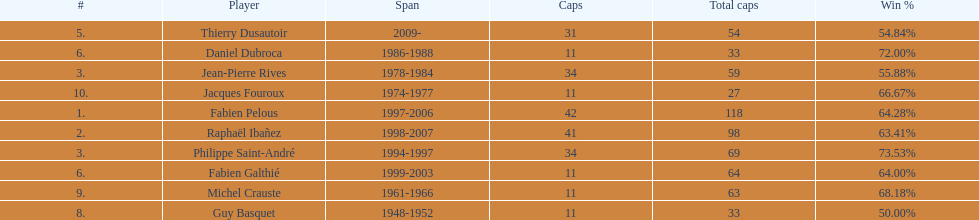How many caps did jean-pierre rives and michel crauste accrue? 122. 